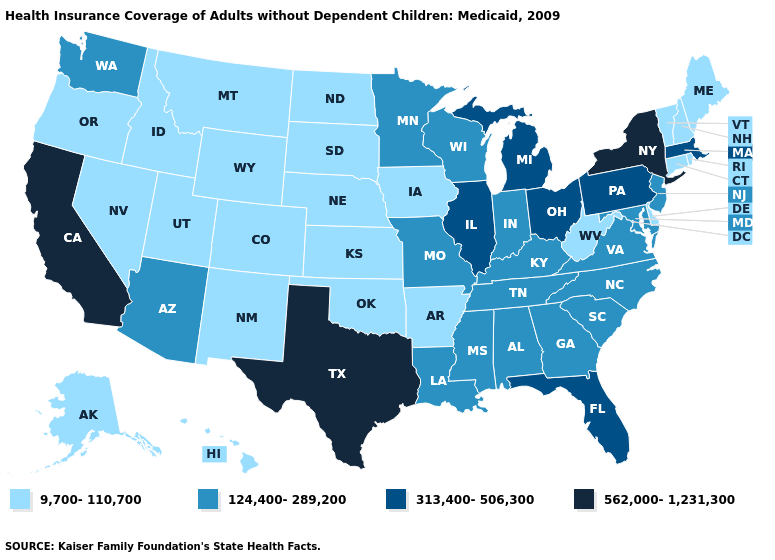Name the states that have a value in the range 124,400-289,200?
Keep it brief. Alabama, Arizona, Georgia, Indiana, Kentucky, Louisiana, Maryland, Minnesota, Mississippi, Missouri, New Jersey, North Carolina, South Carolina, Tennessee, Virginia, Washington, Wisconsin. Which states hav the highest value in the West?
Give a very brief answer. California. Is the legend a continuous bar?
Keep it brief. No. Among the states that border Arizona , which have the highest value?
Quick response, please. California. What is the lowest value in the MidWest?
Keep it brief. 9,700-110,700. What is the highest value in states that border Florida?
Be succinct. 124,400-289,200. Does the first symbol in the legend represent the smallest category?
Give a very brief answer. Yes. Name the states that have a value in the range 9,700-110,700?
Be succinct. Alaska, Arkansas, Colorado, Connecticut, Delaware, Hawaii, Idaho, Iowa, Kansas, Maine, Montana, Nebraska, Nevada, New Hampshire, New Mexico, North Dakota, Oklahoma, Oregon, Rhode Island, South Dakota, Utah, Vermont, West Virginia, Wyoming. Does Maine have the lowest value in the USA?
Concise answer only. Yes. Which states have the lowest value in the West?
Give a very brief answer. Alaska, Colorado, Hawaii, Idaho, Montana, Nevada, New Mexico, Oregon, Utah, Wyoming. Name the states that have a value in the range 124,400-289,200?
Short answer required. Alabama, Arizona, Georgia, Indiana, Kentucky, Louisiana, Maryland, Minnesota, Mississippi, Missouri, New Jersey, North Carolina, South Carolina, Tennessee, Virginia, Washington, Wisconsin. Does Washington have the same value as Rhode Island?
Concise answer only. No. Does Idaho have the same value as Vermont?
Write a very short answer. Yes. Name the states that have a value in the range 124,400-289,200?
Answer briefly. Alabama, Arizona, Georgia, Indiana, Kentucky, Louisiana, Maryland, Minnesota, Mississippi, Missouri, New Jersey, North Carolina, South Carolina, Tennessee, Virginia, Washington, Wisconsin. What is the value of Wisconsin?
Keep it brief. 124,400-289,200. 